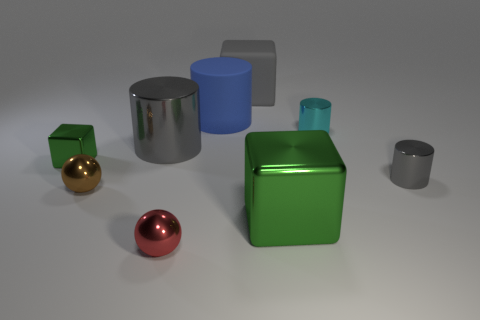What size is the brown thing that is the same material as the small cyan cylinder?
Your answer should be very brief. Small. How many tiny brown objects have the same shape as the small red metallic thing?
Your response must be concise. 1. How many big rubber things are there?
Give a very brief answer. 2. There is a green shiny object on the right side of the small cube; is its shape the same as the brown metal thing?
Make the answer very short. No. There is a gray thing that is the same size as the cyan metal cylinder; what is its material?
Your answer should be very brief. Metal. Is there a tiny yellow cube that has the same material as the cyan thing?
Ensure brevity in your answer.  No. There is a blue thing; is its shape the same as the large metal object that is in front of the small gray object?
Keep it short and to the point. No. What number of objects are behind the tiny gray metal cylinder and left of the tiny cyan cylinder?
Ensure brevity in your answer.  4. Does the tiny gray cylinder have the same material as the gray object behind the blue rubber thing?
Your response must be concise. No. Is the number of small red spheres on the right side of the gray matte object the same as the number of big gray rubber objects?
Give a very brief answer. No. 